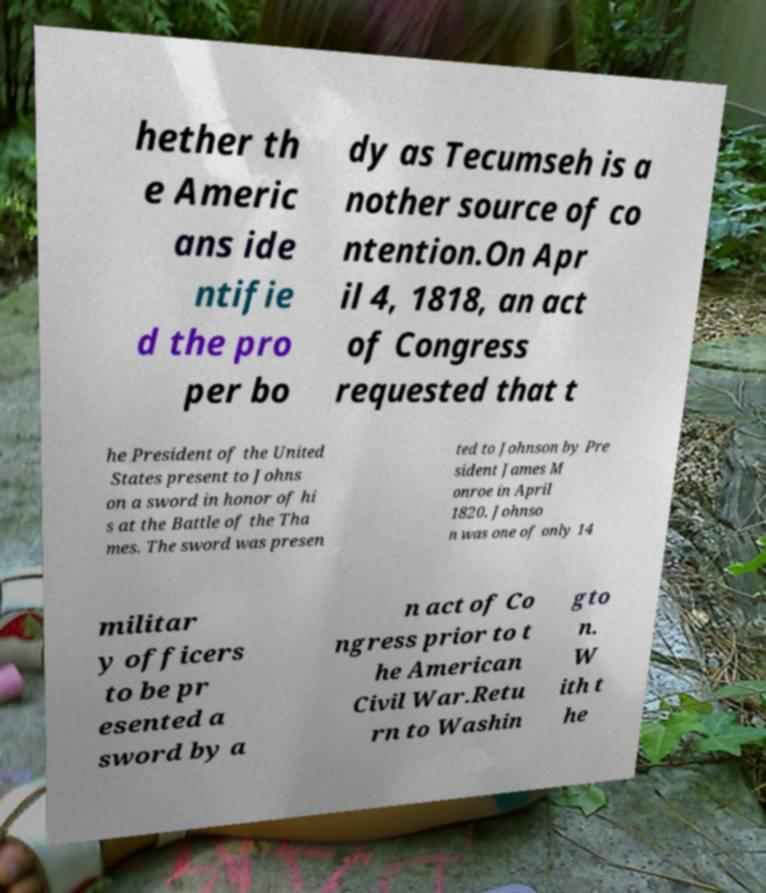Can you accurately transcribe the text from the provided image for me? hether th e Americ ans ide ntifie d the pro per bo dy as Tecumseh is a nother source of co ntention.On Apr il 4, 1818, an act of Congress requested that t he President of the United States present to Johns on a sword in honor of hi s at the Battle of the Tha mes. The sword was presen ted to Johnson by Pre sident James M onroe in April 1820. Johnso n was one of only 14 militar y officers to be pr esented a sword by a n act of Co ngress prior to t he American Civil War.Retu rn to Washin gto n. W ith t he 